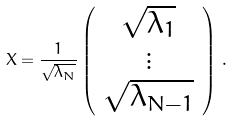Convert formula to latex. <formula><loc_0><loc_0><loc_500><loc_500>X = \frac { 1 } { \sqrt { \lambda _ { N } } } \left ( \begin{array} { c } \sqrt { \lambda _ { 1 } } \\ \vdots \\ \sqrt { \lambda _ { N - 1 } } \end{array} \right ) \, .</formula> 